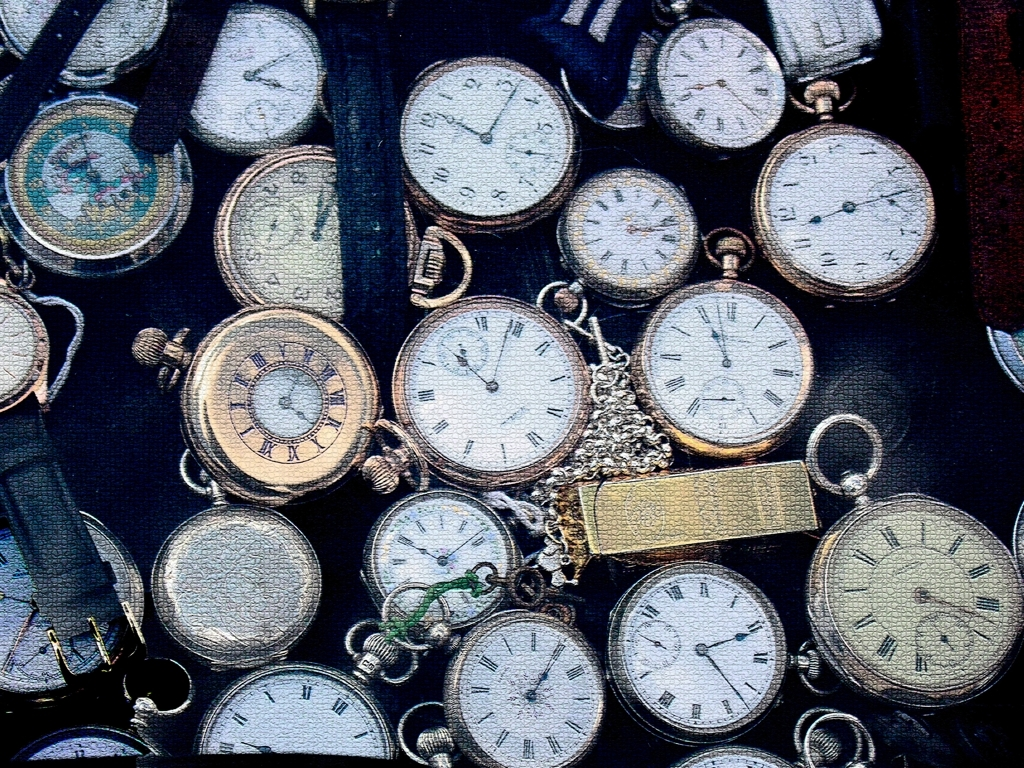Can you describe the variety of watches seen in this image? Certainly! The image displays an assortment of pocket watches with varying styles and periods. Some watches have roman numerals, others have standard digits, and a few feature ornate hands. The chains attached range from simple links to more decorative ones. This variety suggests a collection that could span different eras and possibly serve as a visual history of pocket watch design. 